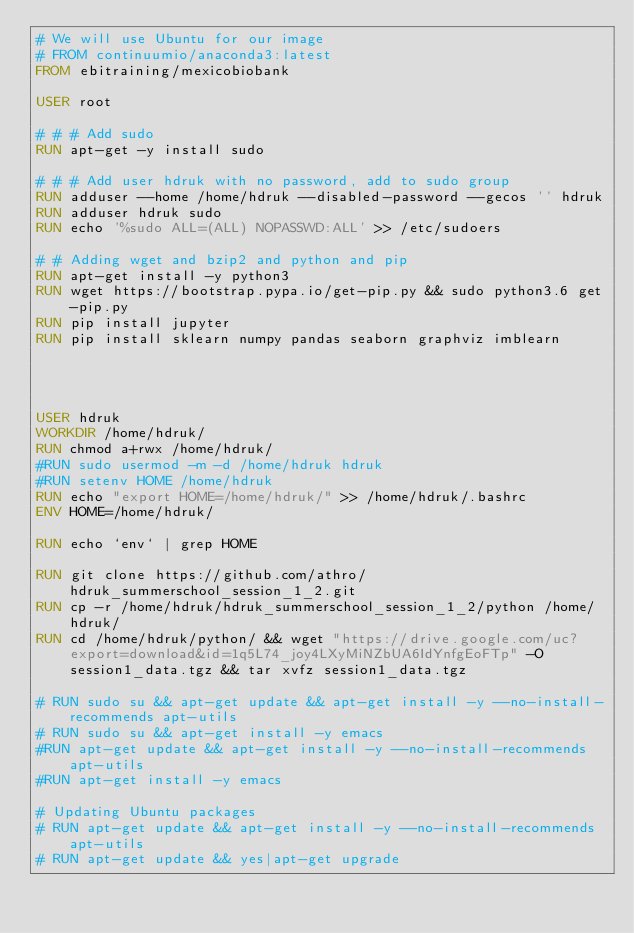Convert code to text. <code><loc_0><loc_0><loc_500><loc_500><_Dockerfile_># We will use Ubuntu for our image
# FROM continuumio/anaconda3:latest
FROM ebitraining/mexicobiobank

USER root

# # # Add sudo
RUN apt-get -y install sudo

# # # Add user hdruk with no password, add to sudo group
RUN adduser --home /home/hdruk --disabled-password --gecos '' hdruk
RUN adduser hdruk sudo
RUN echo '%sudo ALL=(ALL) NOPASSWD:ALL' >> /etc/sudoers

# # Adding wget and bzip2 and python and pip
RUN apt-get install -y python3
RUN wget https://bootstrap.pypa.io/get-pip.py && sudo python3.6 get-pip.py
RUN pip install jupyter
RUN pip install sklearn numpy pandas seaborn graphviz imblearn




USER hdruk
WORKDIR /home/hdruk/
RUN chmod a+rwx /home/hdruk/
#RUN sudo usermod -m -d /home/hdruk hdruk
#RUN setenv HOME /home/hdruk
RUN echo "export HOME=/home/hdruk/" >> /home/hdruk/.bashrc
ENV HOME=/home/hdruk/

RUN echo `env` | grep HOME

RUN git clone https://github.com/athro/hdruk_summerschool_session_1_2.git
RUN cp -r /home/hdruk/hdruk_summerschool_session_1_2/python /home/hdruk/
RUN cd /home/hdruk/python/ && wget "https://drive.google.com/uc?export=download&id=1q5L74_joy4LXyMiNZbUA6IdYnfgEoFTp" -O session1_data.tgz && tar xvfz session1_data.tgz

# RUN sudo su && apt-get update && apt-get install -y --no-install-recommends apt-utils
# RUN sudo su && apt-get install -y emacs
#RUN apt-get update && apt-get install -y --no-install-recommends apt-utils
#RUN apt-get install -y emacs

# Updating Ubuntu packages
# RUN apt-get update && apt-get install -y --no-install-recommends apt-utils
# RUN apt-get update && yes|apt-get upgrade





</code> 